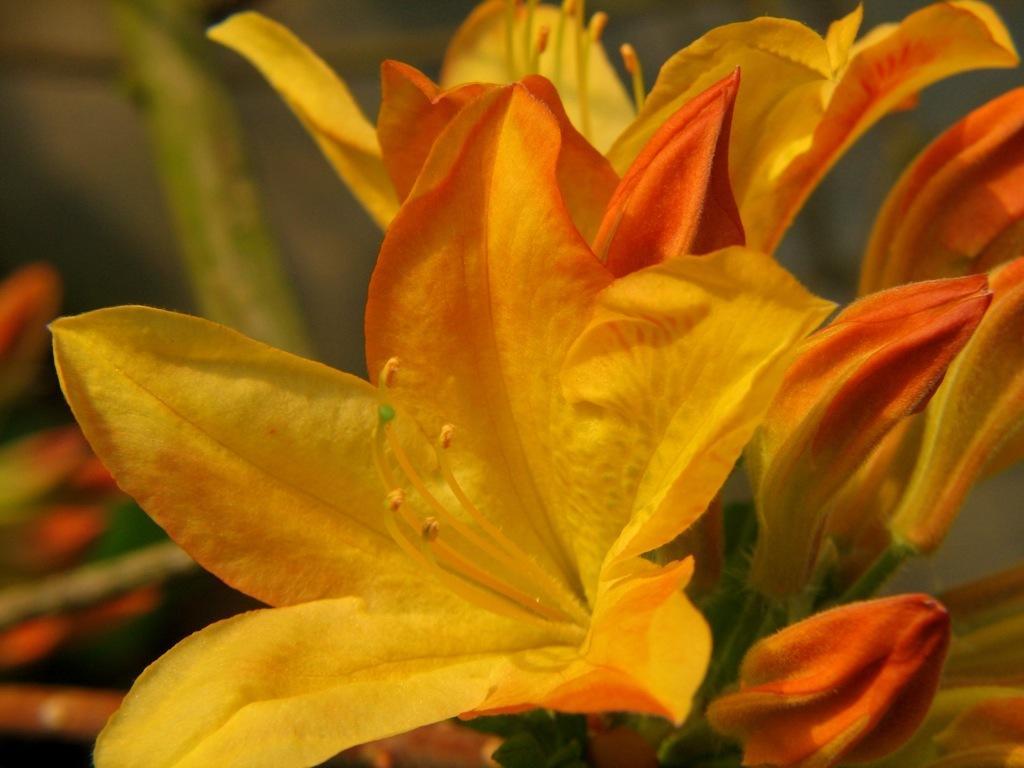Can you describe this image briefly? In this picture we can see flowers and in the background it is blurry. 